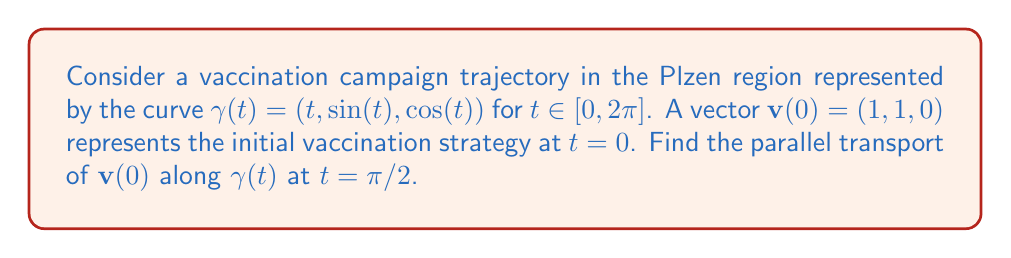Solve this math problem. To solve this problem, we'll follow these steps:

1) First, we need to calculate the tangent vector $\mathbf{T}(t)$ to the curve:
   $$\mathbf{T}(t) = \gamma'(t) = (1, \cos(t), -\sin(t))$$

2) Next, we need to find the normal vector $\mathbf{N}(t)$:
   $$\mathbf{N}(t) = \frac{\mathbf{T}'(t)}{|\mathbf{T}'(t)|} = \frac{(0, -\sin(t), -\cos(t))}{\sqrt{\sin^2(t) + \cos^2(t)}} = (0, -\sin(t), -\cos(t))$$

3) The binormal vector $\mathbf{B}(t)$ is given by:
   $$\mathbf{B}(t) = \mathbf{T}(t) \times \mathbf{N}(t) = (\sin^2(t) + \cos^2(t), \sin(t), \cos(t)) = (1, \sin(t), \cos(t))$$

4) The parallel transport equation is:
   $$\frac{d\mathbf{v}}{dt} + \Gamma(\mathbf{T}, \mathbf{v}) = 0$$
   where $\Gamma$ is the connection coefficient.

5) For a curve in $\mathbb{R}^3$, the connection coefficient is given by:
   $$\Gamma(\mathbf{T}, \mathbf{v}) = (\mathbf{v} \cdot \mathbf{N})\mathbf{T}' + (\mathbf{v} \cdot \mathbf{B})\mathbf{N}'$$

6) Substituting into the parallel transport equation:
   $$\frac{d\mathbf{v}}{dt} + (\mathbf{v} \cdot \mathbf{N})\mathbf{T}' + (\mathbf{v} \cdot \mathbf{B})\mathbf{N}' = 0$$

7) Let $\mathbf{v}(t) = (x(t), y(t), z(t))$. Substituting and solving component-wise:
   $$\begin{cases}
   x'(t) = 0 \\
   y'(t) = -z(t) \\
   z'(t) = y(t)
   \end{cases}$$

8) With initial conditions $x(0) = 1$, $y(0) = 1$, $z(0) = 0$, the solution is:
   $$\mathbf{v}(t) = (1, \cos(t), \sin(t))$$

9) At $t = \pi/2$:
   $$\mathbf{v}(\pi/2) = (1, 0, 1)$$
Answer: $(1, 0, 1)$ 